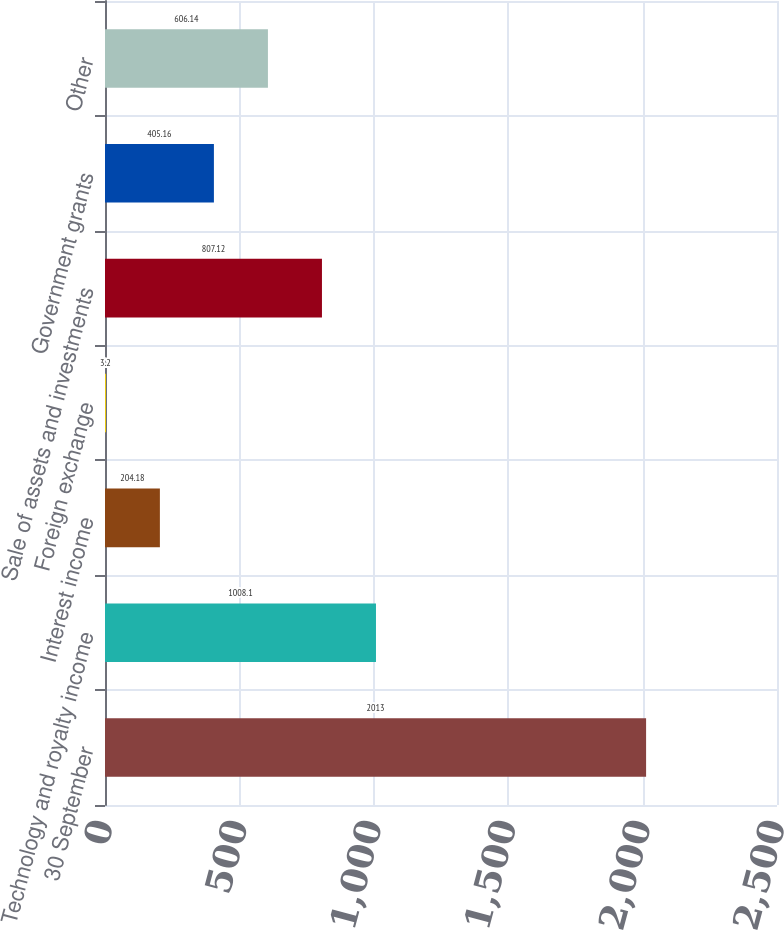<chart> <loc_0><loc_0><loc_500><loc_500><bar_chart><fcel>30 September<fcel>Technology and royalty income<fcel>Interest income<fcel>Foreign exchange<fcel>Sale of assets and investments<fcel>Government grants<fcel>Other<nl><fcel>2013<fcel>1008.1<fcel>204.18<fcel>3.2<fcel>807.12<fcel>405.16<fcel>606.14<nl></chart> 